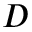<formula> <loc_0><loc_0><loc_500><loc_500>D</formula> 